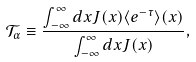Convert formula to latex. <formula><loc_0><loc_0><loc_500><loc_500>\mathcal { T } _ { \alpha } \equiv \frac { \int _ { - \infty } ^ { \infty } d x J ( x ) \langle e ^ { - \tau } \rangle ( x ) } { \int _ { - \infty } ^ { \infty } d x J ( x ) } ,</formula> 